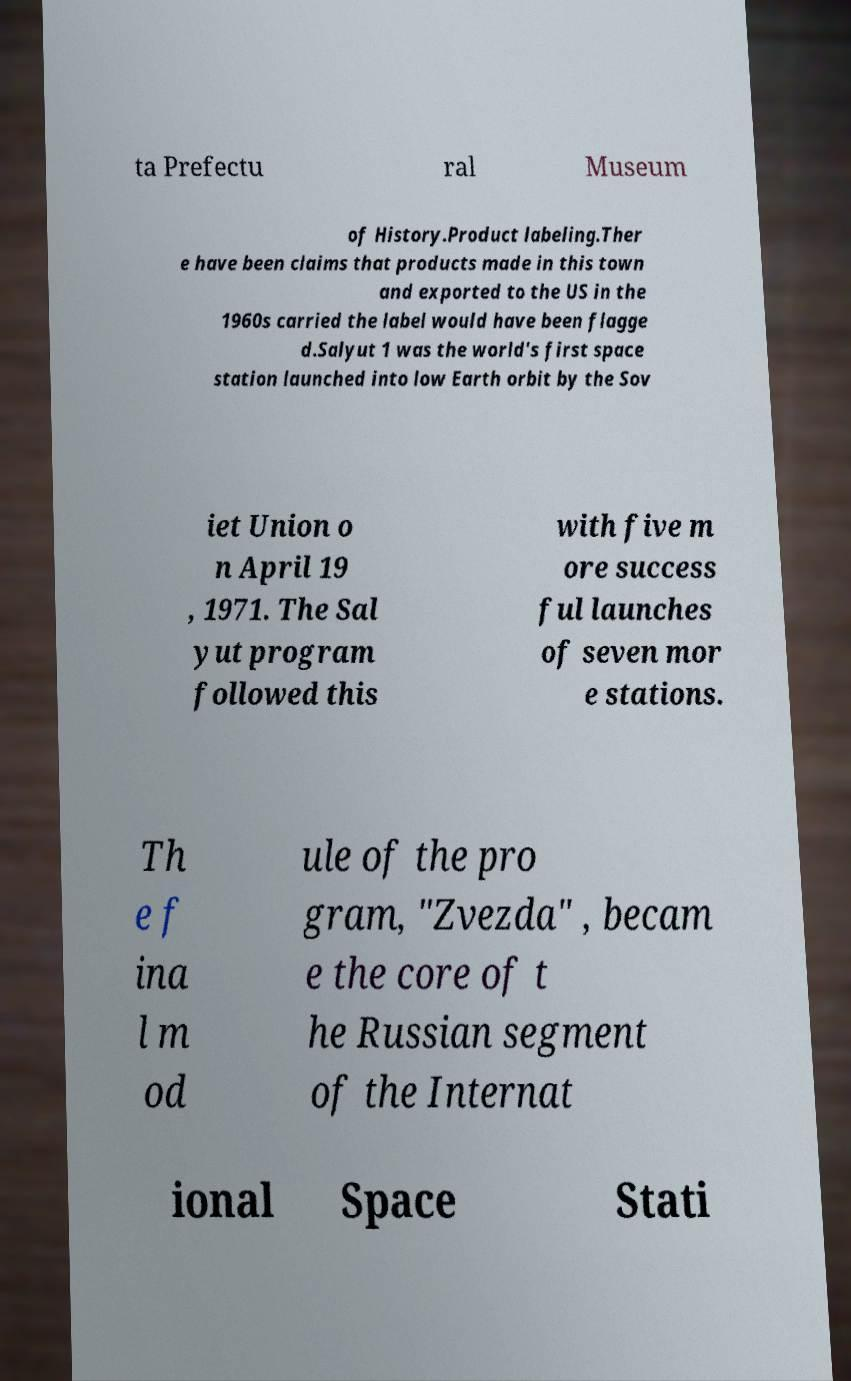Could you assist in decoding the text presented in this image and type it out clearly? ta Prefectu ral Museum of History.Product labeling.Ther e have been claims that products made in this town and exported to the US in the 1960s carried the label would have been flagge d.Salyut 1 was the world's first space station launched into low Earth orbit by the Sov iet Union o n April 19 , 1971. The Sal yut program followed this with five m ore success ful launches of seven mor e stations. Th e f ina l m od ule of the pro gram, "Zvezda" , becam e the core of t he Russian segment of the Internat ional Space Stati 